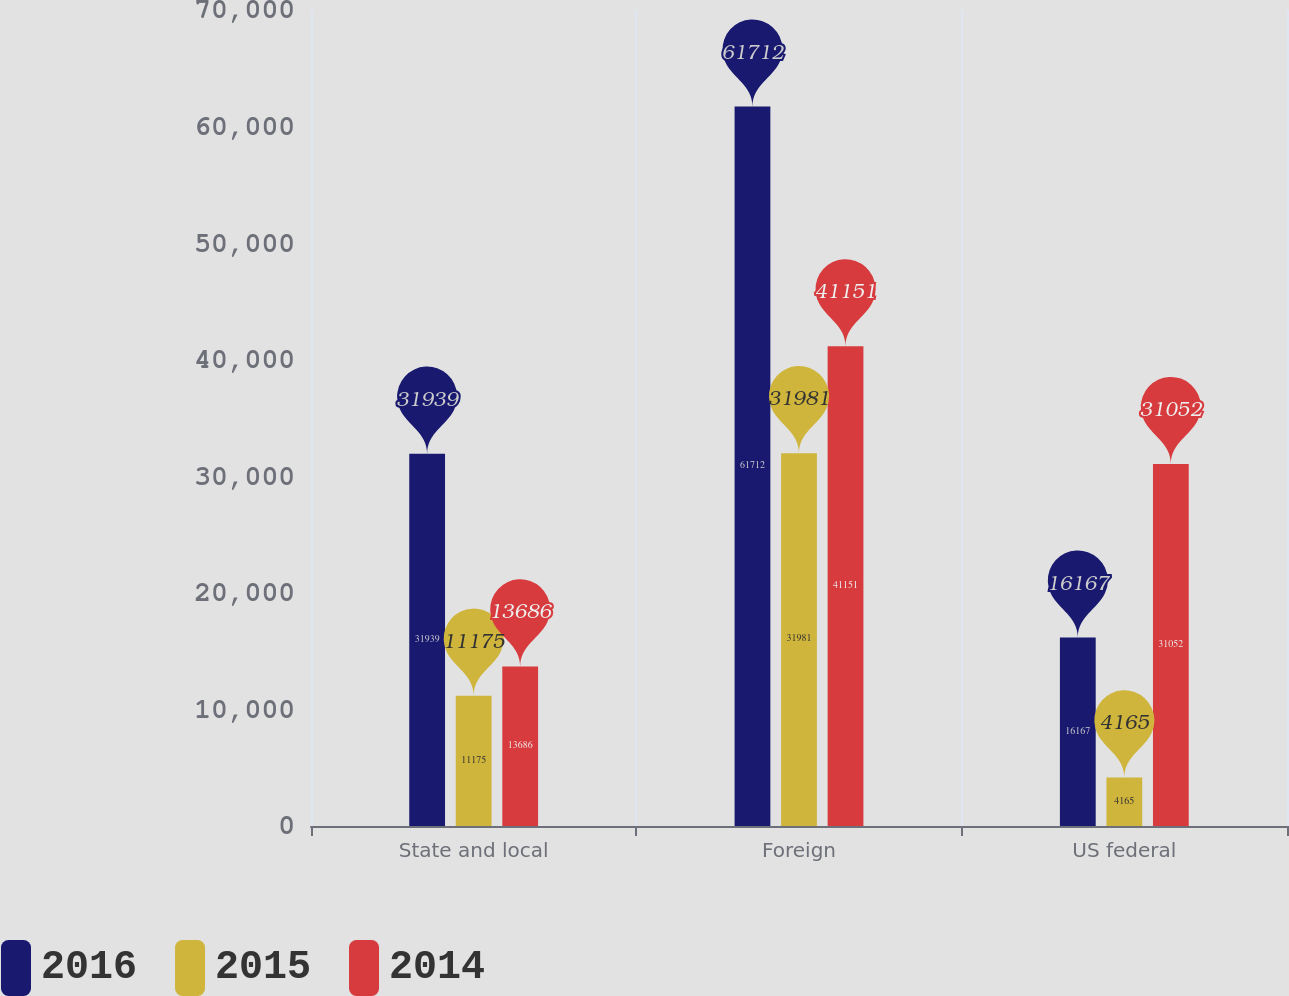Convert chart to OTSL. <chart><loc_0><loc_0><loc_500><loc_500><stacked_bar_chart><ecel><fcel>State and local<fcel>Foreign<fcel>US federal<nl><fcel>2016<fcel>31939<fcel>61712<fcel>16167<nl><fcel>2015<fcel>11175<fcel>31981<fcel>4165<nl><fcel>2014<fcel>13686<fcel>41151<fcel>31052<nl></chart> 